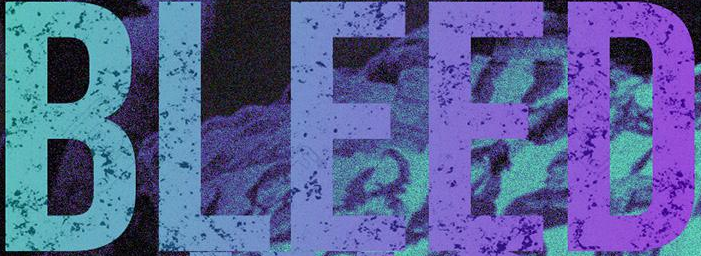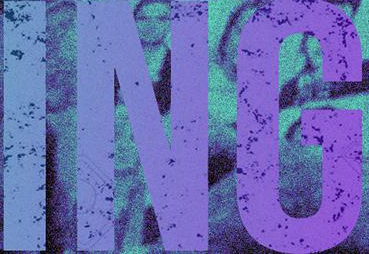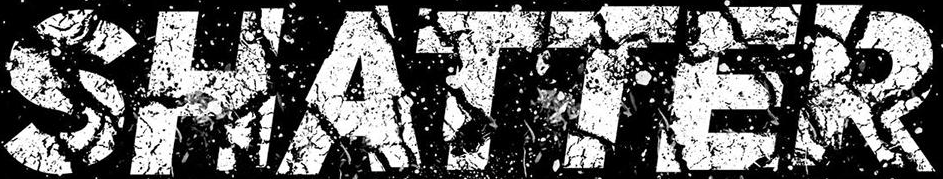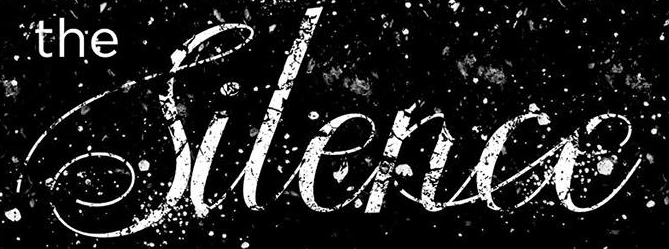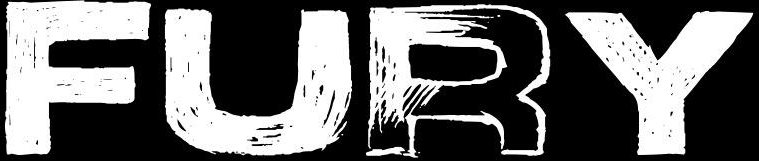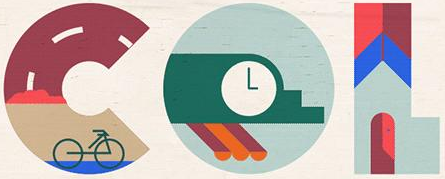What text appears in these images from left to right, separated by a semicolon? BLEED; ING; SHATTER; Silence; FURY; COL 